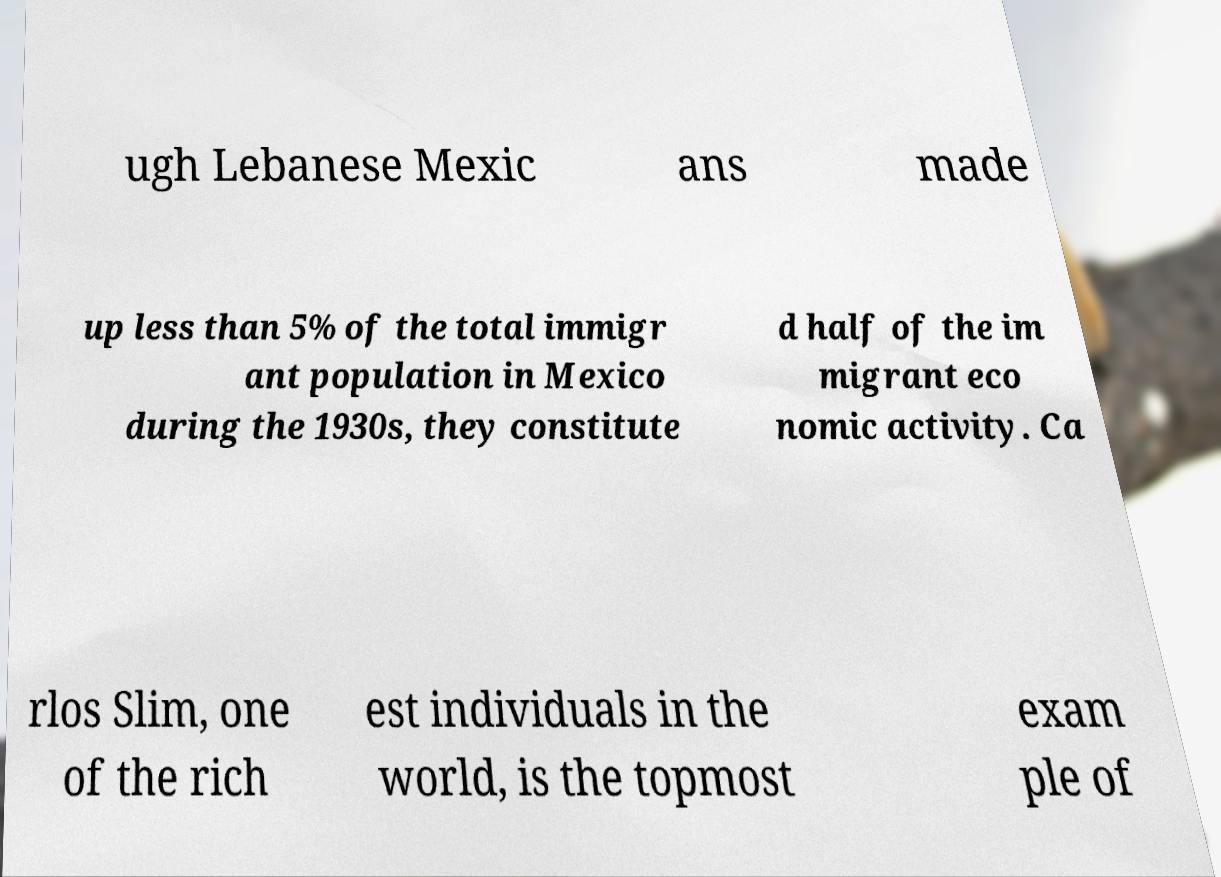Can you accurately transcribe the text from the provided image for me? ugh Lebanese Mexic ans made up less than 5% of the total immigr ant population in Mexico during the 1930s, they constitute d half of the im migrant eco nomic activity. Ca rlos Slim, one of the rich est individuals in the world, is the topmost exam ple of 